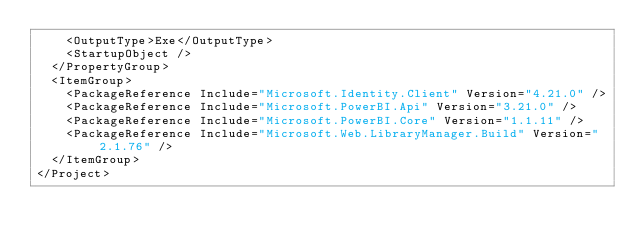Convert code to text. <code><loc_0><loc_0><loc_500><loc_500><_XML_>    <OutputType>Exe</OutputType>
    <StartupObject />
  </PropertyGroup>
  <ItemGroup>
    <PackageReference Include="Microsoft.Identity.Client" Version="4.21.0" />
    <PackageReference Include="Microsoft.PowerBI.Api" Version="3.21.0" />
    <PackageReference Include="Microsoft.PowerBI.Core" Version="1.1.11" />
    <PackageReference Include="Microsoft.Web.LibraryManager.Build" Version="2.1.76" />
  </ItemGroup>
</Project></code> 